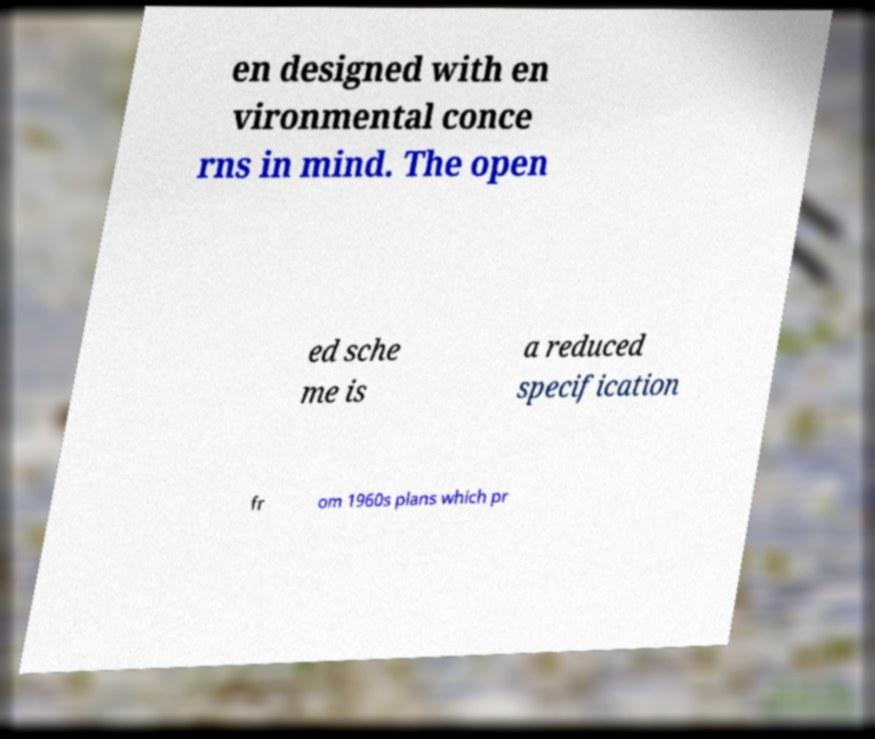What messages or text are displayed in this image? I need them in a readable, typed format. en designed with en vironmental conce rns in mind. The open ed sche me is a reduced specification fr om 1960s plans which pr 